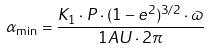Convert formula to latex. <formula><loc_0><loc_0><loc_500><loc_500>\alpha _ { \min } = \frac { K _ { 1 } \cdot P \cdot ( 1 - e ^ { 2 } ) ^ { 3 / 2 } \cdot \varpi } { 1 A U \cdot 2 \pi }</formula> 